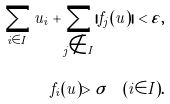Convert formula to latex. <formula><loc_0><loc_0><loc_500><loc_500>\sum _ { i \in I } u _ { i } + \sum _ { j \notin I } | f _ { j } ( u ) | < \varepsilon , \\ f _ { i } ( u ) > \sigma \quad ( i \in I ) .</formula> 